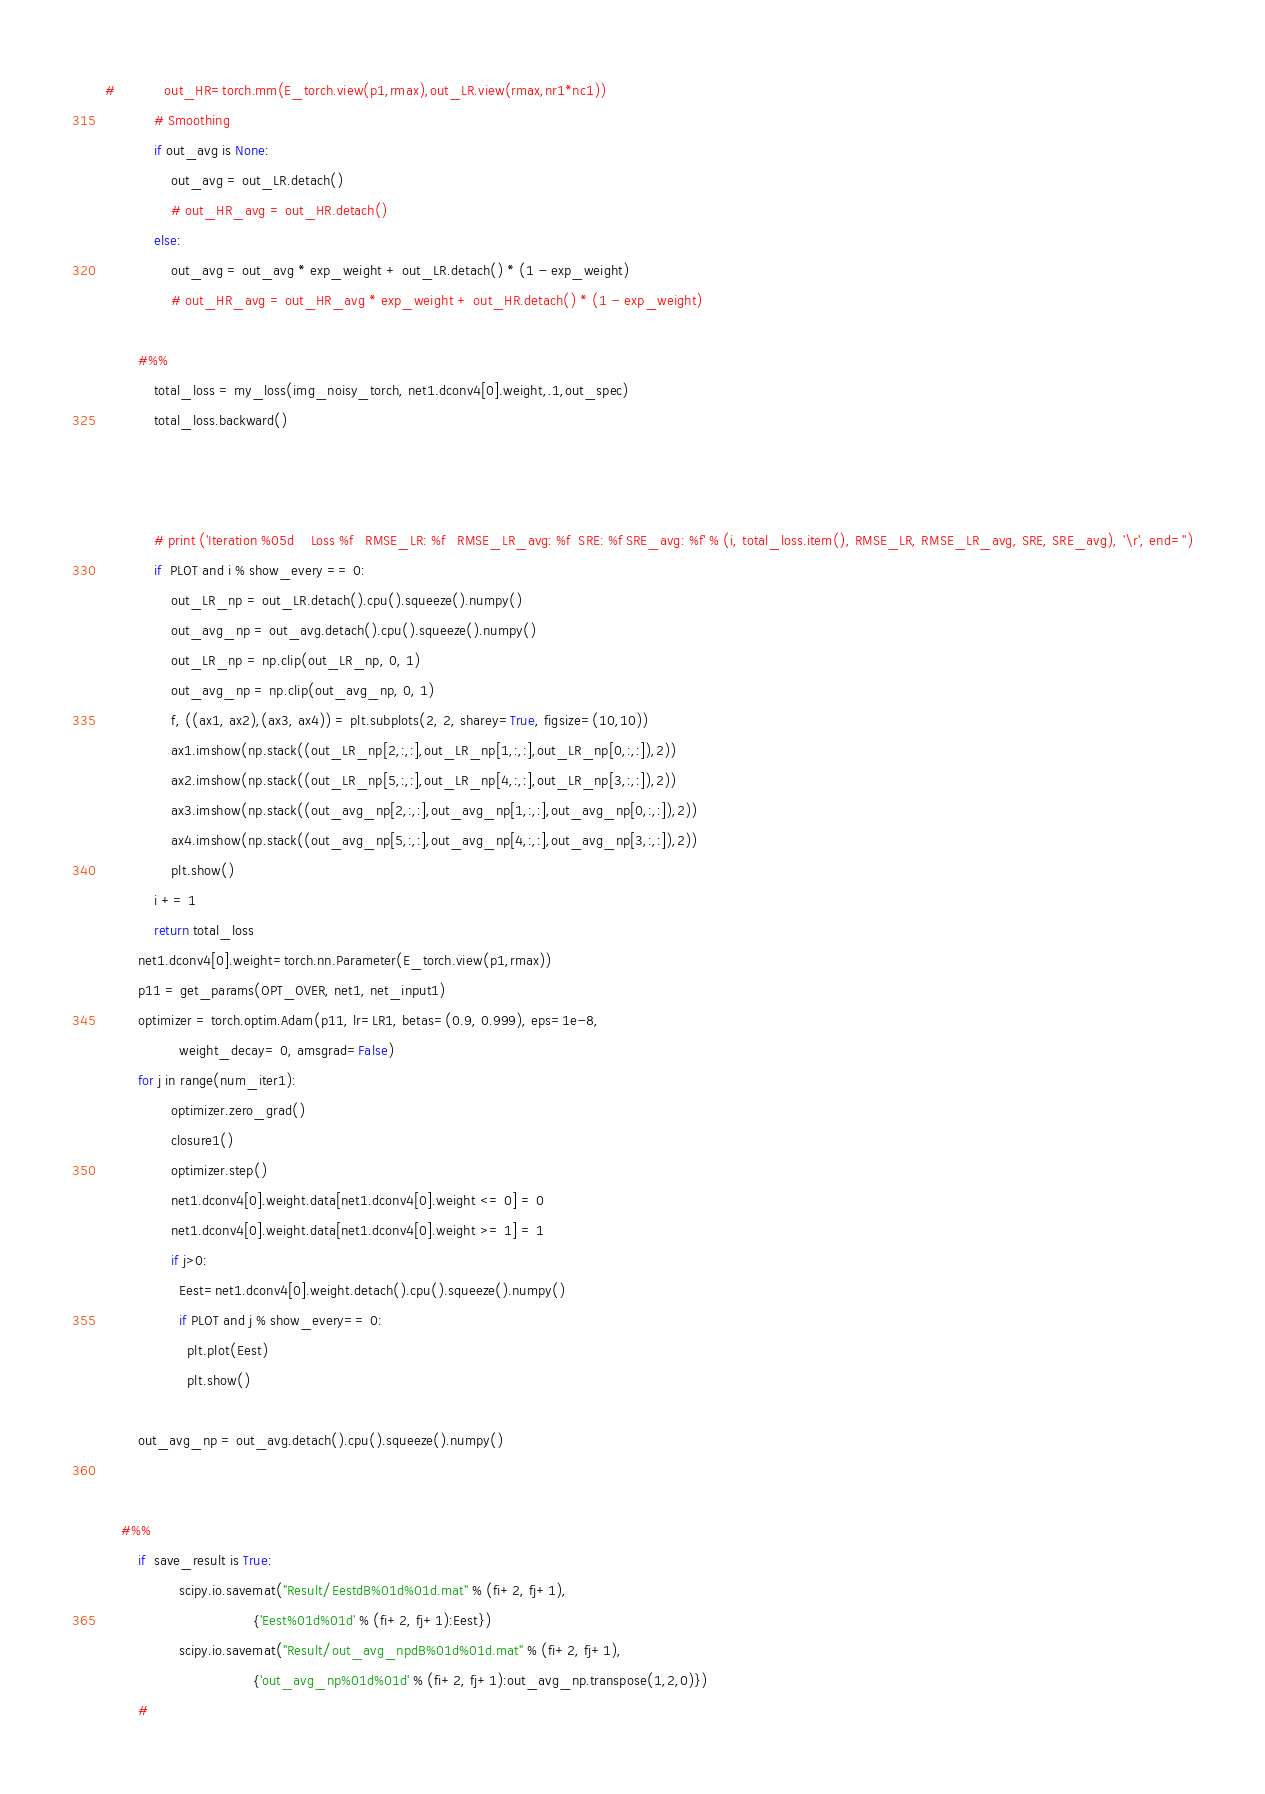<code> <loc_0><loc_0><loc_500><loc_500><_Python_>#            out_HR=torch.mm(E_torch.view(p1,rmax),out_LR.view(rmax,nr1*nc1))
            # Smoothing
            if out_avg is None:
                out_avg = out_LR.detach()
                # out_HR_avg = out_HR.detach()
            else:
                out_avg = out_avg * exp_weight + out_LR.detach() * (1 - exp_weight)
                # out_HR_avg = out_HR_avg * exp_weight + out_HR.detach() * (1 - exp_weight)

        #%%
            total_loss = my_loss(img_noisy_torch, net1.dconv4[0].weight,.1,out_spec)
            total_loss.backward()
         
          

            # print ('Iteration %05d    Loss %f   RMSE_LR: %f   RMSE_LR_avg: %f  SRE: %f SRE_avg: %f' % (i, total_loss.item(), RMSE_LR, RMSE_LR_avg, SRE, SRE_avg), '\r', end='')
            if  PLOT and i % show_every == 0:
                out_LR_np = out_LR.detach().cpu().squeeze().numpy()
                out_avg_np = out_avg.detach().cpu().squeeze().numpy()
                out_LR_np = np.clip(out_LR_np, 0, 1)
                out_avg_np = np.clip(out_avg_np, 0, 1)    
                f, ((ax1, ax2),(ax3, ax4)) = plt.subplots(2, 2, sharey=True, figsize=(10,10))
                ax1.imshow(np.stack((out_LR_np[2,:,:],out_LR_np[1,:,:],out_LR_np[0,:,:]),2))
                ax2.imshow(np.stack((out_LR_np[5,:,:],out_LR_np[4,:,:],out_LR_np[3,:,:]),2))
                ax3.imshow(np.stack((out_avg_np[2,:,:],out_avg_np[1,:,:],out_avg_np[0,:,:]),2))
                ax4.imshow(np.stack((out_avg_np[5,:,:],out_avg_np[4,:,:],out_avg_np[3,:,:]),2))
                plt.show()                   
            i += 1       
            return total_loss
        net1.dconv4[0].weight=torch.nn.Parameter(E_torch.view(p1,rmax))       
        p11 = get_params(OPT_OVER, net1, net_input1)
        optimizer = torch.optim.Adam(p11, lr=LR1, betas=(0.9, 0.999), eps=1e-8,
                  weight_decay= 0, amsgrad=False)
        for j in range(num_iter1):
                optimizer.zero_grad()
                closure1()  
                optimizer.step()
                net1.dconv4[0].weight.data[net1.dconv4[0].weight <= 0] = 0
                net1.dconv4[0].weight.data[net1.dconv4[0].weight >= 1] = 1
                if j>0:
                  Eest=net1.dconv4[0].weight.detach().cpu().squeeze().numpy()
                  if PLOT and j % show_every== 0: 
                    plt.plot(Eest)
                    plt.show()
                  
        out_avg_np = out_avg.detach().cpu().squeeze().numpy()
       

    #%%
        if  save_result is True:
                  scipy.io.savemat("Result/EestdB%01d%01d.mat" % (fi+2, fj+1),
                                    {'Eest%01d%01d' % (fi+2, fj+1):Eest})
                  scipy.io.savemat("Result/out_avg_npdB%01d%01d.mat" % (fi+2, fj+1),
                                    {'out_avg_np%01d%01d' % (fi+2, fj+1):out_avg_np.transpose(1,2,0)})
        #
</code> 